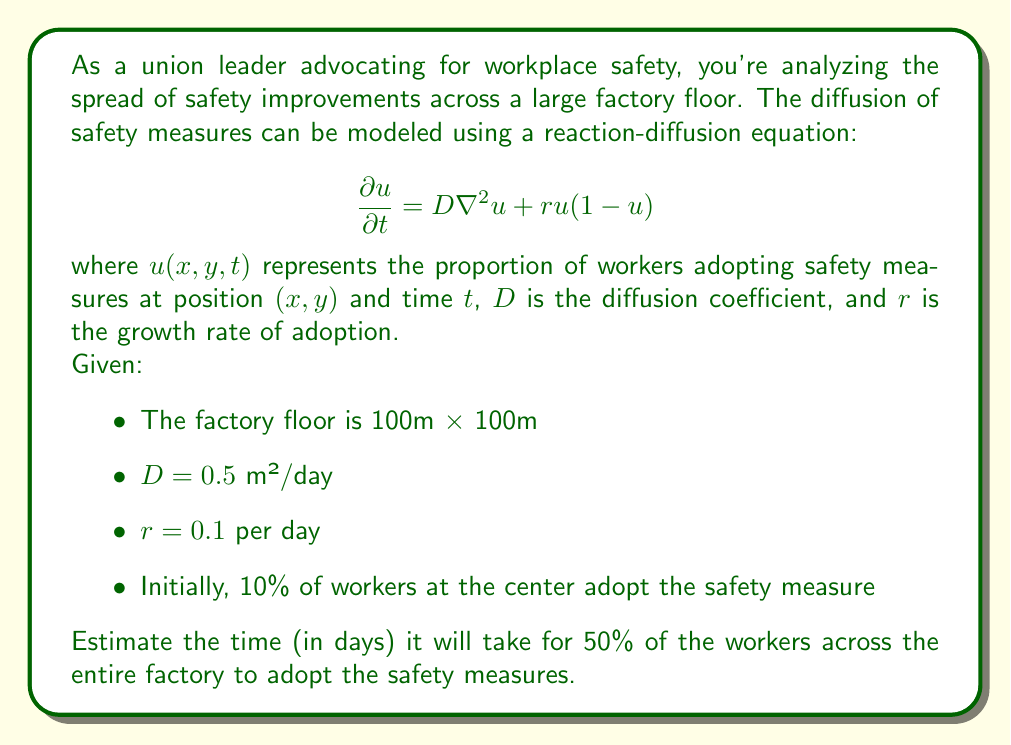Can you solve this math problem? To solve this problem, we need to use the Fisher-KPP equation, which is a special case of the reaction-diffusion equation. The speed of the traveling wave front for this equation is given by:

$$c = 2\sqrt{Dr}$$

1. Calculate the wave speed:
   $$c = 2\sqrt{0.5 \cdot 0.1} = 2\sqrt{0.05} \approx 0.447 \text{ m/day}$$

2. Estimate the distance the wave needs to travel:
   The initial adoption is at the center, so the wave needs to reach the corners of the factory.
   The distance to a corner is half the diagonal of the square:
   $$\text{distance} = \frac{\sqrt{100^2 + 100^2}}{2} = \frac{100\sqrt{2}}{2} \approx 70.71 \text{ m}$$

3. Estimate the time for the wave to reach the corners:
   $$\text{time} = \frac{\text{distance}}{\text{speed}} = \frac{70.71}{0.447} \approx 158.19 \text{ days}$$

4. Add a buffer for complete adoption:
   The wave reaching the corners doesn't guarantee 50% adoption across the entire factory. We'll add a 20% buffer to account for this.

   $$\text{total time} = 158.19 \cdot 1.2 \approx 189.83 \text{ days}$$

This is an estimate based on the traveling wave speed of the Fisher-KPP equation. The actual time may vary due to the complex dynamics of the system, but this provides a reasonable approximation for planning purposes.
Answer: Approximately 190 days 